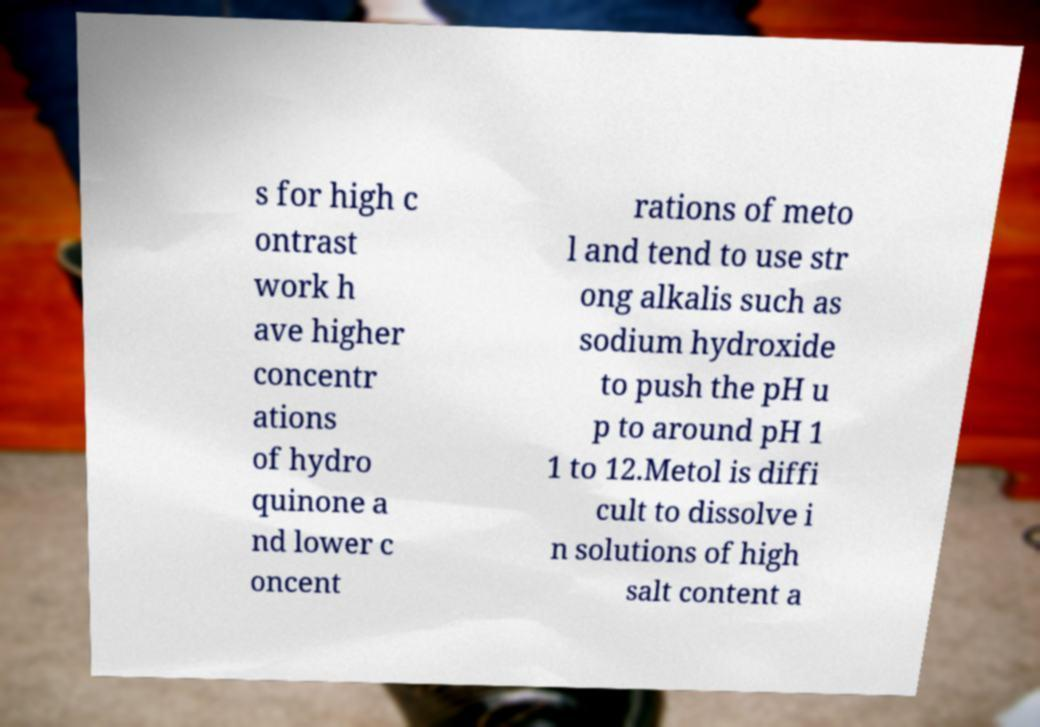Could you extract and type out the text from this image? s for high c ontrast work h ave higher concentr ations of hydro quinone a nd lower c oncent rations of meto l and tend to use str ong alkalis such as sodium hydroxide to push the pH u p to around pH 1 1 to 12.Metol is diffi cult to dissolve i n solutions of high salt content a 